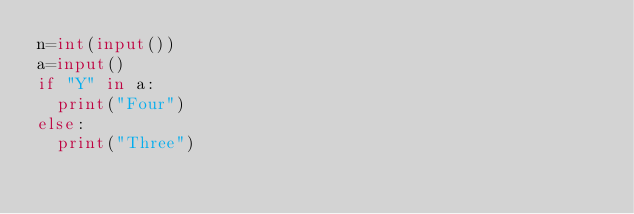Convert code to text. <code><loc_0><loc_0><loc_500><loc_500><_Python_>n=int(input())
a=input()
if "Y" in a:
  print("Four")
else:
  print("Three")</code> 